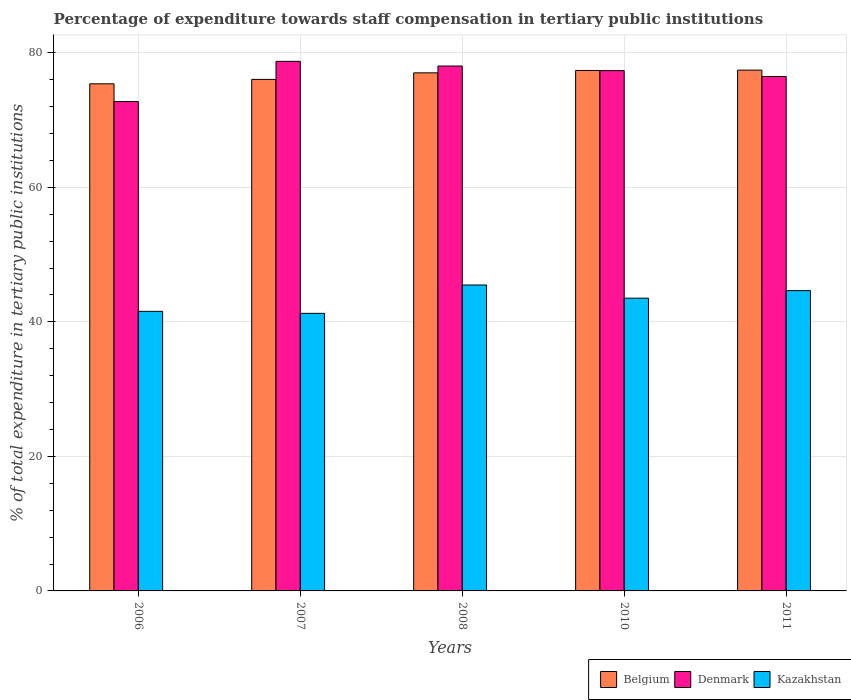How many different coloured bars are there?
Offer a terse response. 3. Are the number of bars per tick equal to the number of legend labels?
Provide a succinct answer. Yes. How many bars are there on the 2nd tick from the right?
Ensure brevity in your answer.  3. What is the percentage of expenditure towards staff compensation in Belgium in 2011?
Your answer should be compact. 77.43. Across all years, what is the maximum percentage of expenditure towards staff compensation in Belgium?
Your answer should be very brief. 77.43. Across all years, what is the minimum percentage of expenditure towards staff compensation in Kazakhstan?
Your response must be concise. 41.27. In which year was the percentage of expenditure towards staff compensation in Belgium minimum?
Provide a short and direct response. 2006. What is the total percentage of expenditure towards staff compensation in Belgium in the graph?
Provide a succinct answer. 383.28. What is the difference between the percentage of expenditure towards staff compensation in Belgium in 2006 and that in 2007?
Offer a very short reply. -0.65. What is the difference between the percentage of expenditure towards staff compensation in Kazakhstan in 2007 and the percentage of expenditure towards staff compensation in Belgium in 2011?
Make the answer very short. -36.16. What is the average percentage of expenditure towards staff compensation in Belgium per year?
Provide a succinct answer. 76.66. In the year 2011, what is the difference between the percentage of expenditure towards staff compensation in Denmark and percentage of expenditure towards staff compensation in Belgium?
Your answer should be compact. -0.95. In how many years, is the percentage of expenditure towards staff compensation in Kazakhstan greater than 56 %?
Your response must be concise. 0. What is the ratio of the percentage of expenditure towards staff compensation in Denmark in 2006 to that in 2007?
Your answer should be compact. 0.92. What is the difference between the highest and the second highest percentage of expenditure towards staff compensation in Belgium?
Ensure brevity in your answer.  0.05. What is the difference between the highest and the lowest percentage of expenditure towards staff compensation in Belgium?
Make the answer very short. 2.04. Is the sum of the percentage of expenditure towards staff compensation in Belgium in 2006 and 2010 greater than the maximum percentage of expenditure towards staff compensation in Kazakhstan across all years?
Make the answer very short. Yes. What does the 2nd bar from the right in 2006 represents?
Offer a very short reply. Denmark. Is it the case that in every year, the sum of the percentage of expenditure towards staff compensation in Denmark and percentage of expenditure towards staff compensation in Belgium is greater than the percentage of expenditure towards staff compensation in Kazakhstan?
Your answer should be compact. Yes. How many bars are there?
Give a very brief answer. 15. How many years are there in the graph?
Your answer should be compact. 5. What is the difference between two consecutive major ticks on the Y-axis?
Your answer should be compact. 20. Are the values on the major ticks of Y-axis written in scientific E-notation?
Your answer should be compact. No. Does the graph contain any zero values?
Your answer should be compact. No. How many legend labels are there?
Keep it short and to the point. 3. What is the title of the graph?
Provide a short and direct response. Percentage of expenditure towards staff compensation in tertiary public institutions. What is the label or title of the Y-axis?
Ensure brevity in your answer.  % of total expenditure in tertiary public institutions. What is the % of total expenditure in tertiary public institutions of Belgium in 2006?
Provide a short and direct response. 75.39. What is the % of total expenditure in tertiary public institutions in Denmark in 2006?
Make the answer very short. 72.76. What is the % of total expenditure in tertiary public institutions in Kazakhstan in 2006?
Provide a short and direct response. 41.57. What is the % of total expenditure in tertiary public institutions in Belgium in 2007?
Ensure brevity in your answer.  76.05. What is the % of total expenditure in tertiary public institutions of Denmark in 2007?
Your answer should be compact. 78.73. What is the % of total expenditure in tertiary public institutions in Kazakhstan in 2007?
Provide a succinct answer. 41.27. What is the % of total expenditure in tertiary public institutions of Belgium in 2008?
Provide a succinct answer. 77.03. What is the % of total expenditure in tertiary public institutions in Denmark in 2008?
Offer a terse response. 78.04. What is the % of total expenditure in tertiary public institutions in Kazakhstan in 2008?
Offer a very short reply. 45.48. What is the % of total expenditure in tertiary public institutions in Belgium in 2010?
Give a very brief answer. 77.38. What is the % of total expenditure in tertiary public institutions in Denmark in 2010?
Your answer should be compact. 77.35. What is the % of total expenditure in tertiary public institutions in Kazakhstan in 2010?
Provide a succinct answer. 43.52. What is the % of total expenditure in tertiary public institutions of Belgium in 2011?
Your answer should be very brief. 77.43. What is the % of total expenditure in tertiary public institutions in Denmark in 2011?
Offer a very short reply. 76.48. What is the % of total expenditure in tertiary public institutions of Kazakhstan in 2011?
Your answer should be very brief. 44.65. Across all years, what is the maximum % of total expenditure in tertiary public institutions in Belgium?
Offer a very short reply. 77.43. Across all years, what is the maximum % of total expenditure in tertiary public institutions in Denmark?
Provide a succinct answer. 78.73. Across all years, what is the maximum % of total expenditure in tertiary public institutions in Kazakhstan?
Your response must be concise. 45.48. Across all years, what is the minimum % of total expenditure in tertiary public institutions of Belgium?
Your answer should be compact. 75.39. Across all years, what is the minimum % of total expenditure in tertiary public institutions of Denmark?
Your answer should be compact. 72.76. Across all years, what is the minimum % of total expenditure in tertiary public institutions in Kazakhstan?
Provide a succinct answer. 41.27. What is the total % of total expenditure in tertiary public institutions of Belgium in the graph?
Keep it short and to the point. 383.28. What is the total % of total expenditure in tertiary public institutions of Denmark in the graph?
Provide a short and direct response. 383.36. What is the total % of total expenditure in tertiary public institutions of Kazakhstan in the graph?
Your answer should be compact. 216.49. What is the difference between the % of total expenditure in tertiary public institutions in Belgium in 2006 and that in 2007?
Provide a short and direct response. -0.65. What is the difference between the % of total expenditure in tertiary public institutions in Denmark in 2006 and that in 2007?
Offer a terse response. -5.98. What is the difference between the % of total expenditure in tertiary public institutions in Kazakhstan in 2006 and that in 2007?
Offer a very short reply. 0.3. What is the difference between the % of total expenditure in tertiary public institutions of Belgium in 2006 and that in 2008?
Provide a short and direct response. -1.63. What is the difference between the % of total expenditure in tertiary public institutions of Denmark in 2006 and that in 2008?
Ensure brevity in your answer.  -5.28. What is the difference between the % of total expenditure in tertiary public institutions in Kazakhstan in 2006 and that in 2008?
Offer a terse response. -3.92. What is the difference between the % of total expenditure in tertiary public institutions in Belgium in 2006 and that in 2010?
Provide a short and direct response. -1.98. What is the difference between the % of total expenditure in tertiary public institutions of Denmark in 2006 and that in 2010?
Offer a very short reply. -4.6. What is the difference between the % of total expenditure in tertiary public institutions of Kazakhstan in 2006 and that in 2010?
Give a very brief answer. -1.96. What is the difference between the % of total expenditure in tertiary public institutions of Belgium in 2006 and that in 2011?
Provide a short and direct response. -2.04. What is the difference between the % of total expenditure in tertiary public institutions of Denmark in 2006 and that in 2011?
Ensure brevity in your answer.  -3.73. What is the difference between the % of total expenditure in tertiary public institutions of Kazakhstan in 2006 and that in 2011?
Your answer should be compact. -3.08. What is the difference between the % of total expenditure in tertiary public institutions of Belgium in 2007 and that in 2008?
Provide a short and direct response. -0.98. What is the difference between the % of total expenditure in tertiary public institutions of Denmark in 2007 and that in 2008?
Give a very brief answer. 0.69. What is the difference between the % of total expenditure in tertiary public institutions in Kazakhstan in 2007 and that in 2008?
Ensure brevity in your answer.  -4.22. What is the difference between the % of total expenditure in tertiary public institutions of Belgium in 2007 and that in 2010?
Offer a terse response. -1.33. What is the difference between the % of total expenditure in tertiary public institutions in Denmark in 2007 and that in 2010?
Offer a very short reply. 1.38. What is the difference between the % of total expenditure in tertiary public institutions in Kazakhstan in 2007 and that in 2010?
Give a very brief answer. -2.26. What is the difference between the % of total expenditure in tertiary public institutions of Belgium in 2007 and that in 2011?
Your answer should be very brief. -1.38. What is the difference between the % of total expenditure in tertiary public institutions in Denmark in 2007 and that in 2011?
Provide a short and direct response. 2.25. What is the difference between the % of total expenditure in tertiary public institutions of Kazakhstan in 2007 and that in 2011?
Give a very brief answer. -3.38. What is the difference between the % of total expenditure in tertiary public institutions of Belgium in 2008 and that in 2010?
Keep it short and to the point. -0.35. What is the difference between the % of total expenditure in tertiary public institutions of Denmark in 2008 and that in 2010?
Make the answer very short. 0.69. What is the difference between the % of total expenditure in tertiary public institutions in Kazakhstan in 2008 and that in 2010?
Your answer should be compact. 1.96. What is the difference between the % of total expenditure in tertiary public institutions in Belgium in 2008 and that in 2011?
Provide a short and direct response. -0.4. What is the difference between the % of total expenditure in tertiary public institutions of Denmark in 2008 and that in 2011?
Make the answer very short. 1.55. What is the difference between the % of total expenditure in tertiary public institutions in Kazakhstan in 2008 and that in 2011?
Ensure brevity in your answer.  0.84. What is the difference between the % of total expenditure in tertiary public institutions of Belgium in 2010 and that in 2011?
Give a very brief answer. -0.05. What is the difference between the % of total expenditure in tertiary public institutions of Denmark in 2010 and that in 2011?
Keep it short and to the point. 0.87. What is the difference between the % of total expenditure in tertiary public institutions of Kazakhstan in 2010 and that in 2011?
Provide a succinct answer. -1.12. What is the difference between the % of total expenditure in tertiary public institutions of Belgium in 2006 and the % of total expenditure in tertiary public institutions of Denmark in 2007?
Give a very brief answer. -3.34. What is the difference between the % of total expenditure in tertiary public institutions in Belgium in 2006 and the % of total expenditure in tertiary public institutions in Kazakhstan in 2007?
Your answer should be very brief. 34.13. What is the difference between the % of total expenditure in tertiary public institutions of Denmark in 2006 and the % of total expenditure in tertiary public institutions of Kazakhstan in 2007?
Offer a very short reply. 31.49. What is the difference between the % of total expenditure in tertiary public institutions in Belgium in 2006 and the % of total expenditure in tertiary public institutions in Denmark in 2008?
Provide a short and direct response. -2.64. What is the difference between the % of total expenditure in tertiary public institutions of Belgium in 2006 and the % of total expenditure in tertiary public institutions of Kazakhstan in 2008?
Make the answer very short. 29.91. What is the difference between the % of total expenditure in tertiary public institutions of Denmark in 2006 and the % of total expenditure in tertiary public institutions of Kazakhstan in 2008?
Offer a terse response. 27.27. What is the difference between the % of total expenditure in tertiary public institutions in Belgium in 2006 and the % of total expenditure in tertiary public institutions in Denmark in 2010?
Provide a succinct answer. -1.96. What is the difference between the % of total expenditure in tertiary public institutions in Belgium in 2006 and the % of total expenditure in tertiary public institutions in Kazakhstan in 2010?
Make the answer very short. 31.87. What is the difference between the % of total expenditure in tertiary public institutions of Denmark in 2006 and the % of total expenditure in tertiary public institutions of Kazakhstan in 2010?
Provide a succinct answer. 29.23. What is the difference between the % of total expenditure in tertiary public institutions in Belgium in 2006 and the % of total expenditure in tertiary public institutions in Denmark in 2011?
Offer a terse response. -1.09. What is the difference between the % of total expenditure in tertiary public institutions in Belgium in 2006 and the % of total expenditure in tertiary public institutions in Kazakhstan in 2011?
Keep it short and to the point. 30.75. What is the difference between the % of total expenditure in tertiary public institutions in Denmark in 2006 and the % of total expenditure in tertiary public institutions in Kazakhstan in 2011?
Your answer should be compact. 28.11. What is the difference between the % of total expenditure in tertiary public institutions in Belgium in 2007 and the % of total expenditure in tertiary public institutions in Denmark in 2008?
Offer a terse response. -1.99. What is the difference between the % of total expenditure in tertiary public institutions in Belgium in 2007 and the % of total expenditure in tertiary public institutions in Kazakhstan in 2008?
Give a very brief answer. 30.57. What is the difference between the % of total expenditure in tertiary public institutions in Denmark in 2007 and the % of total expenditure in tertiary public institutions in Kazakhstan in 2008?
Provide a succinct answer. 33.25. What is the difference between the % of total expenditure in tertiary public institutions of Belgium in 2007 and the % of total expenditure in tertiary public institutions of Denmark in 2010?
Offer a terse response. -1.3. What is the difference between the % of total expenditure in tertiary public institutions in Belgium in 2007 and the % of total expenditure in tertiary public institutions in Kazakhstan in 2010?
Your response must be concise. 32.52. What is the difference between the % of total expenditure in tertiary public institutions of Denmark in 2007 and the % of total expenditure in tertiary public institutions of Kazakhstan in 2010?
Keep it short and to the point. 35.21. What is the difference between the % of total expenditure in tertiary public institutions of Belgium in 2007 and the % of total expenditure in tertiary public institutions of Denmark in 2011?
Your response must be concise. -0.44. What is the difference between the % of total expenditure in tertiary public institutions of Belgium in 2007 and the % of total expenditure in tertiary public institutions of Kazakhstan in 2011?
Keep it short and to the point. 31.4. What is the difference between the % of total expenditure in tertiary public institutions of Denmark in 2007 and the % of total expenditure in tertiary public institutions of Kazakhstan in 2011?
Make the answer very short. 34.08. What is the difference between the % of total expenditure in tertiary public institutions of Belgium in 2008 and the % of total expenditure in tertiary public institutions of Denmark in 2010?
Offer a very short reply. -0.33. What is the difference between the % of total expenditure in tertiary public institutions in Belgium in 2008 and the % of total expenditure in tertiary public institutions in Kazakhstan in 2010?
Offer a terse response. 33.5. What is the difference between the % of total expenditure in tertiary public institutions of Denmark in 2008 and the % of total expenditure in tertiary public institutions of Kazakhstan in 2010?
Provide a short and direct response. 34.51. What is the difference between the % of total expenditure in tertiary public institutions in Belgium in 2008 and the % of total expenditure in tertiary public institutions in Denmark in 2011?
Offer a very short reply. 0.54. What is the difference between the % of total expenditure in tertiary public institutions in Belgium in 2008 and the % of total expenditure in tertiary public institutions in Kazakhstan in 2011?
Your answer should be very brief. 32.38. What is the difference between the % of total expenditure in tertiary public institutions in Denmark in 2008 and the % of total expenditure in tertiary public institutions in Kazakhstan in 2011?
Offer a terse response. 33.39. What is the difference between the % of total expenditure in tertiary public institutions in Belgium in 2010 and the % of total expenditure in tertiary public institutions in Denmark in 2011?
Your response must be concise. 0.89. What is the difference between the % of total expenditure in tertiary public institutions in Belgium in 2010 and the % of total expenditure in tertiary public institutions in Kazakhstan in 2011?
Provide a succinct answer. 32.73. What is the difference between the % of total expenditure in tertiary public institutions in Denmark in 2010 and the % of total expenditure in tertiary public institutions in Kazakhstan in 2011?
Your response must be concise. 32.7. What is the average % of total expenditure in tertiary public institutions of Belgium per year?
Offer a terse response. 76.66. What is the average % of total expenditure in tertiary public institutions in Denmark per year?
Your response must be concise. 76.67. What is the average % of total expenditure in tertiary public institutions in Kazakhstan per year?
Your answer should be compact. 43.3. In the year 2006, what is the difference between the % of total expenditure in tertiary public institutions of Belgium and % of total expenditure in tertiary public institutions of Denmark?
Keep it short and to the point. 2.64. In the year 2006, what is the difference between the % of total expenditure in tertiary public institutions of Belgium and % of total expenditure in tertiary public institutions of Kazakhstan?
Your response must be concise. 33.83. In the year 2006, what is the difference between the % of total expenditure in tertiary public institutions in Denmark and % of total expenditure in tertiary public institutions in Kazakhstan?
Give a very brief answer. 31.19. In the year 2007, what is the difference between the % of total expenditure in tertiary public institutions of Belgium and % of total expenditure in tertiary public institutions of Denmark?
Ensure brevity in your answer.  -2.68. In the year 2007, what is the difference between the % of total expenditure in tertiary public institutions of Belgium and % of total expenditure in tertiary public institutions of Kazakhstan?
Your answer should be compact. 34.78. In the year 2007, what is the difference between the % of total expenditure in tertiary public institutions of Denmark and % of total expenditure in tertiary public institutions of Kazakhstan?
Ensure brevity in your answer.  37.47. In the year 2008, what is the difference between the % of total expenditure in tertiary public institutions of Belgium and % of total expenditure in tertiary public institutions of Denmark?
Make the answer very short. -1.01. In the year 2008, what is the difference between the % of total expenditure in tertiary public institutions of Belgium and % of total expenditure in tertiary public institutions of Kazakhstan?
Make the answer very short. 31.54. In the year 2008, what is the difference between the % of total expenditure in tertiary public institutions of Denmark and % of total expenditure in tertiary public institutions of Kazakhstan?
Your answer should be compact. 32.55. In the year 2010, what is the difference between the % of total expenditure in tertiary public institutions in Belgium and % of total expenditure in tertiary public institutions in Denmark?
Make the answer very short. 0.03. In the year 2010, what is the difference between the % of total expenditure in tertiary public institutions of Belgium and % of total expenditure in tertiary public institutions of Kazakhstan?
Provide a succinct answer. 33.85. In the year 2010, what is the difference between the % of total expenditure in tertiary public institutions in Denmark and % of total expenditure in tertiary public institutions in Kazakhstan?
Keep it short and to the point. 33.83. In the year 2011, what is the difference between the % of total expenditure in tertiary public institutions of Belgium and % of total expenditure in tertiary public institutions of Denmark?
Offer a terse response. 0.95. In the year 2011, what is the difference between the % of total expenditure in tertiary public institutions of Belgium and % of total expenditure in tertiary public institutions of Kazakhstan?
Provide a succinct answer. 32.78. In the year 2011, what is the difference between the % of total expenditure in tertiary public institutions in Denmark and % of total expenditure in tertiary public institutions in Kazakhstan?
Offer a very short reply. 31.84. What is the ratio of the % of total expenditure in tertiary public institutions in Denmark in 2006 to that in 2007?
Your answer should be compact. 0.92. What is the ratio of the % of total expenditure in tertiary public institutions in Kazakhstan in 2006 to that in 2007?
Your answer should be very brief. 1.01. What is the ratio of the % of total expenditure in tertiary public institutions in Belgium in 2006 to that in 2008?
Ensure brevity in your answer.  0.98. What is the ratio of the % of total expenditure in tertiary public institutions of Denmark in 2006 to that in 2008?
Provide a succinct answer. 0.93. What is the ratio of the % of total expenditure in tertiary public institutions in Kazakhstan in 2006 to that in 2008?
Your answer should be compact. 0.91. What is the ratio of the % of total expenditure in tertiary public institutions in Belgium in 2006 to that in 2010?
Your response must be concise. 0.97. What is the ratio of the % of total expenditure in tertiary public institutions in Denmark in 2006 to that in 2010?
Your response must be concise. 0.94. What is the ratio of the % of total expenditure in tertiary public institutions in Kazakhstan in 2006 to that in 2010?
Make the answer very short. 0.95. What is the ratio of the % of total expenditure in tertiary public institutions in Belgium in 2006 to that in 2011?
Provide a short and direct response. 0.97. What is the ratio of the % of total expenditure in tertiary public institutions of Denmark in 2006 to that in 2011?
Provide a short and direct response. 0.95. What is the ratio of the % of total expenditure in tertiary public institutions in Kazakhstan in 2006 to that in 2011?
Keep it short and to the point. 0.93. What is the ratio of the % of total expenditure in tertiary public institutions in Belgium in 2007 to that in 2008?
Your answer should be compact. 0.99. What is the ratio of the % of total expenditure in tertiary public institutions in Denmark in 2007 to that in 2008?
Ensure brevity in your answer.  1.01. What is the ratio of the % of total expenditure in tertiary public institutions of Kazakhstan in 2007 to that in 2008?
Your response must be concise. 0.91. What is the ratio of the % of total expenditure in tertiary public institutions in Belgium in 2007 to that in 2010?
Offer a very short reply. 0.98. What is the ratio of the % of total expenditure in tertiary public institutions in Denmark in 2007 to that in 2010?
Provide a short and direct response. 1.02. What is the ratio of the % of total expenditure in tertiary public institutions of Kazakhstan in 2007 to that in 2010?
Give a very brief answer. 0.95. What is the ratio of the % of total expenditure in tertiary public institutions in Belgium in 2007 to that in 2011?
Offer a very short reply. 0.98. What is the ratio of the % of total expenditure in tertiary public institutions of Denmark in 2007 to that in 2011?
Offer a terse response. 1.03. What is the ratio of the % of total expenditure in tertiary public institutions in Kazakhstan in 2007 to that in 2011?
Your answer should be very brief. 0.92. What is the ratio of the % of total expenditure in tertiary public institutions of Belgium in 2008 to that in 2010?
Ensure brevity in your answer.  1. What is the ratio of the % of total expenditure in tertiary public institutions of Denmark in 2008 to that in 2010?
Make the answer very short. 1.01. What is the ratio of the % of total expenditure in tertiary public institutions of Kazakhstan in 2008 to that in 2010?
Your answer should be very brief. 1.04. What is the ratio of the % of total expenditure in tertiary public institutions in Denmark in 2008 to that in 2011?
Keep it short and to the point. 1.02. What is the ratio of the % of total expenditure in tertiary public institutions in Kazakhstan in 2008 to that in 2011?
Offer a terse response. 1.02. What is the ratio of the % of total expenditure in tertiary public institutions of Belgium in 2010 to that in 2011?
Provide a succinct answer. 1. What is the ratio of the % of total expenditure in tertiary public institutions of Denmark in 2010 to that in 2011?
Provide a succinct answer. 1.01. What is the ratio of the % of total expenditure in tertiary public institutions of Kazakhstan in 2010 to that in 2011?
Provide a short and direct response. 0.97. What is the difference between the highest and the second highest % of total expenditure in tertiary public institutions in Belgium?
Provide a short and direct response. 0.05. What is the difference between the highest and the second highest % of total expenditure in tertiary public institutions of Denmark?
Offer a very short reply. 0.69. What is the difference between the highest and the second highest % of total expenditure in tertiary public institutions of Kazakhstan?
Your answer should be very brief. 0.84. What is the difference between the highest and the lowest % of total expenditure in tertiary public institutions of Belgium?
Keep it short and to the point. 2.04. What is the difference between the highest and the lowest % of total expenditure in tertiary public institutions of Denmark?
Your answer should be compact. 5.98. What is the difference between the highest and the lowest % of total expenditure in tertiary public institutions in Kazakhstan?
Your answer should be compact. 4.22. 